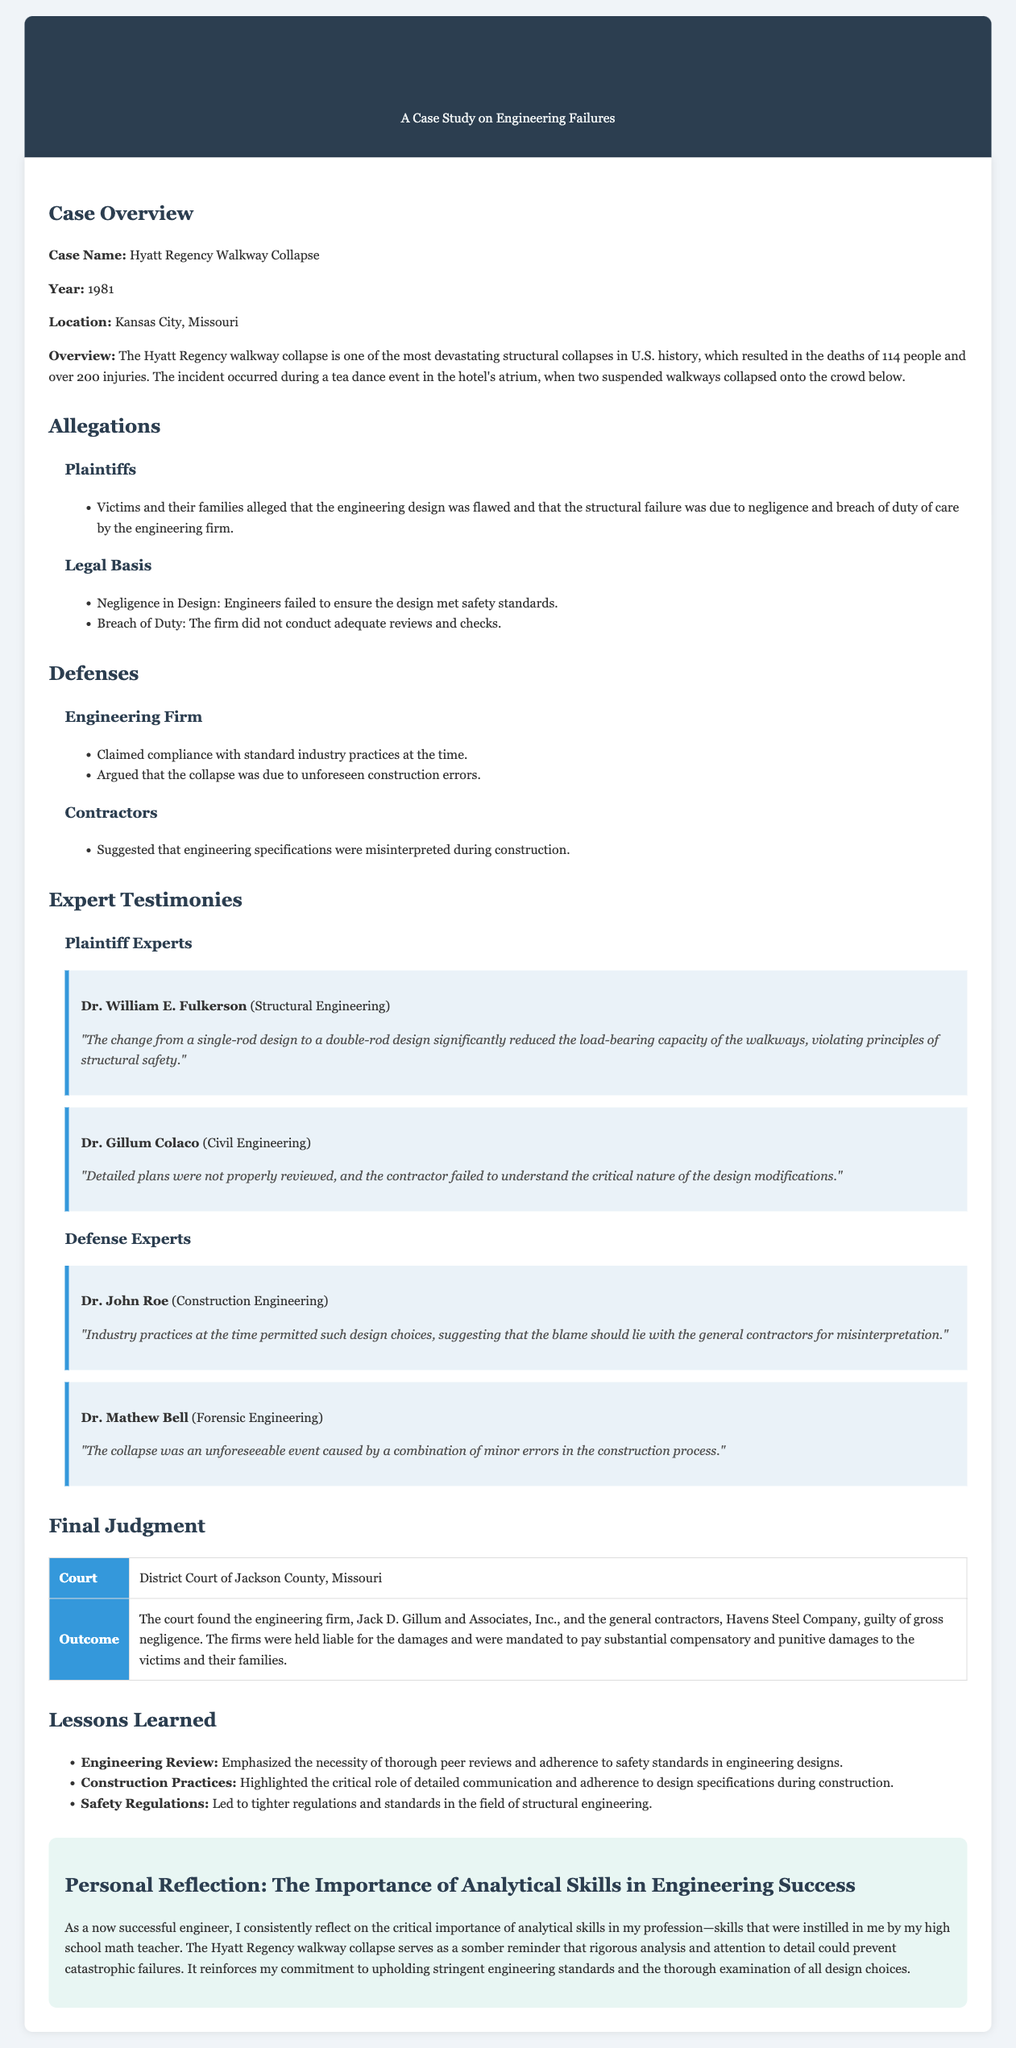What year did the Hyatt Regency walkway collapse occur? The year of the incident is stated clearly in the document under the case overview section.
Answer: 1981 What was the outcome of the litigation case? The outcome is detailed in the final judgment section, summarizing the court's decision on liability.
Answer: The court found the engineering firm and general contractors guilty of gross negligence Who was the structural engineering expert for the plaintiffs? The document specifies the names and credentials of the experts in the expert testimonies section.
Answer: Dr. William E. Fulkerson Which engineering firm was held liable for the damages? The final judgment section explicitly names the firm responsible for the negligence.
Answer: Jack D. Gillum and Associates, Inc What was the main allegation against the engineering firm? The document outlines the allegations in a dedicated section, focusing on the claims made by the plaintiffs.
Answer: Negligence in Design What did the defense argue regarding industry practices? The defenses are summarized in their respective section, focusing on the arguments presented by the engineering firm.
Answer: Compliance with standard industry practices What crucial design change contributed to the walkway collapse according to the plaintiff's experts? The expert testimonies detail specific findings regarding design modifications relevant to the case.
Answer: Change from a single-rod design to a double-rod design What lesson is emphasized regarding engineering reviews? The lessons learned section summarizes key takeaways from the case, specifically on engineering practices.
Answer: Necessity of thorough peer reviews What is highlighted about construction practices in the lessons learned? The lessons learned section addresses critical insights related to construction practices during the case analysis.
Answer: Adherence to design specifications 